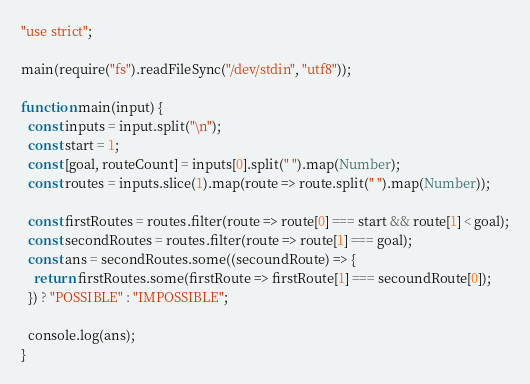<code> <loc_0><loc_0><loc_500><loc_500><_TypeScript_>"use strict";

main(require("fs").readFileSync("/dev/stdin", "utf8"));

function main(input) {
  const inputs = input.split("\n");
  const start = 1;
  const [goal, routeCount] = inputs[0].split(" ").map(Number);
  const routes = inputs.slice(1).map(route => route.split(" ").map(Number));

  const firstRoutes = routes.filter(route => route[0] === start && route[1] < goal);
  const secondRoutes = routes.filter(route => route[1] === goal);
  const ans = secondRoutes.some((secoundRoute) => {
    return firstRoutes.some(firstRoute => firstRoute[1] === secoundRoute[0]);
  }) ? "POSSIBLE" : "IMPOSSIBLE";

  console.log(ans);
}</code> 